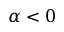<formula> <loc_0><loc_0><loc_500><loc_500>\alpha < 0</formula> 